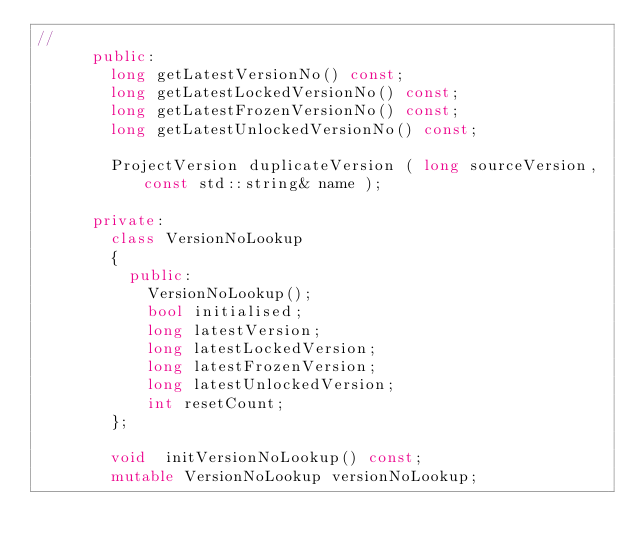<code> <loc_0><loc_0><loc_500><loc_500><_C++_>//
      public:
        long getLatestVersionNo() const;
        long getLatestLockedVersionNo() const;
        long getLatestFrozenVersionNo() const;
        long getLatestUnlockedVersionNo() const;

        ProjectVersion duplicateVersion ( long sourceVersion, const std::string& name );

      private:
        class VersionNoLookup
        {
          public:
            VersionNoLookup();
            bool initialised;
            long latestVersion;
            long latestLockedVersion;
            long latestFrozenVersion;
            long latestUnlockedVersion;
            int resetCount;
        };

        void  initVersionNoLookup() const;
        mutable VersionNoLookup versionNoLookup;


</code> 